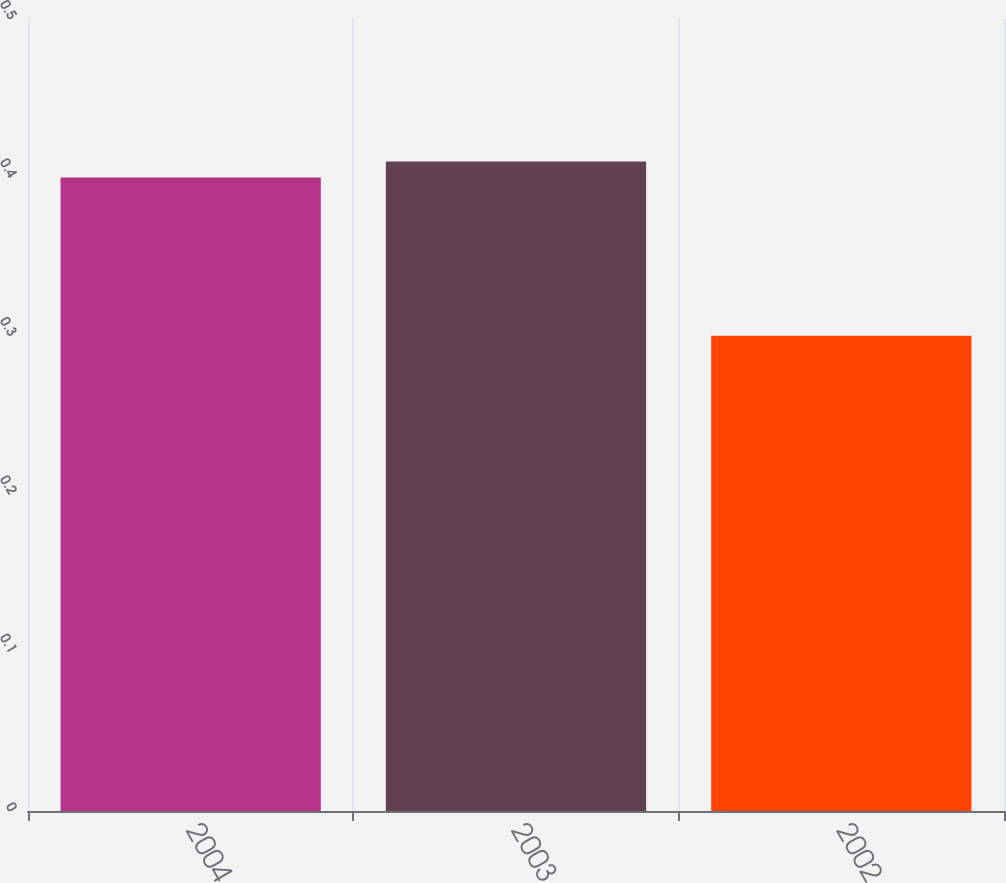<chart> <loc_0><loc_0><loc_500><loc_500><bar_chart><fcel>2004<fcel>2003<fcel>2002<nl><fcel>0.4<fcel>0.41<fcel>0.3<nl></chart> 